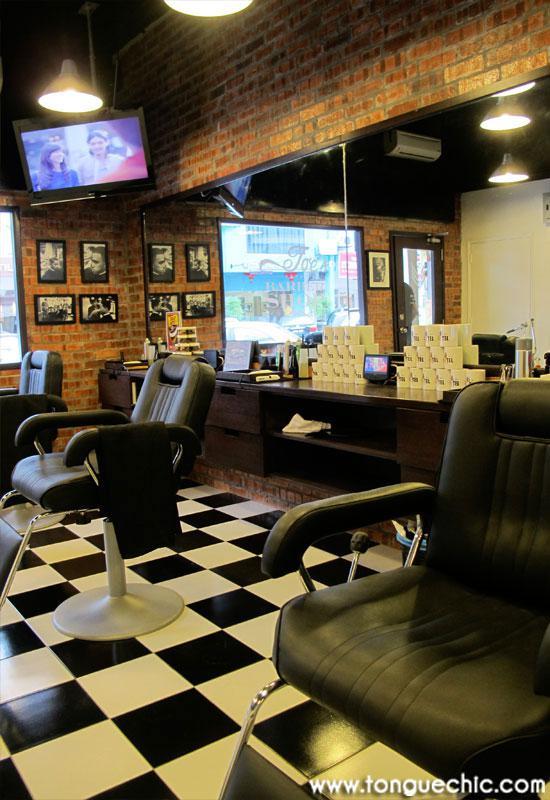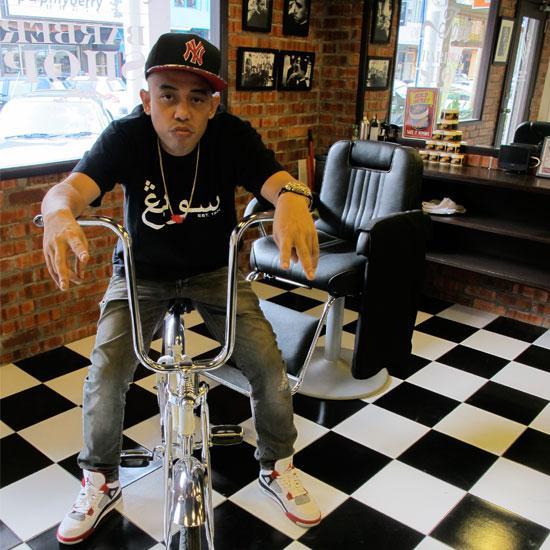The first image is the image on the left, the second image is the image on the right. For the images shown, is this caption "There is a TV mounted high on the wall  in a barbershop with at least three barber chairs available to sit in." true? Answer yes or no. Yes. The first image is the image on the left, the second image is the image on the right. For the images shown, is this caption "In the left image the person furthest to the left is cutting another persons hair that is seated in a barbers chair." true? Answer yes or no. No. 